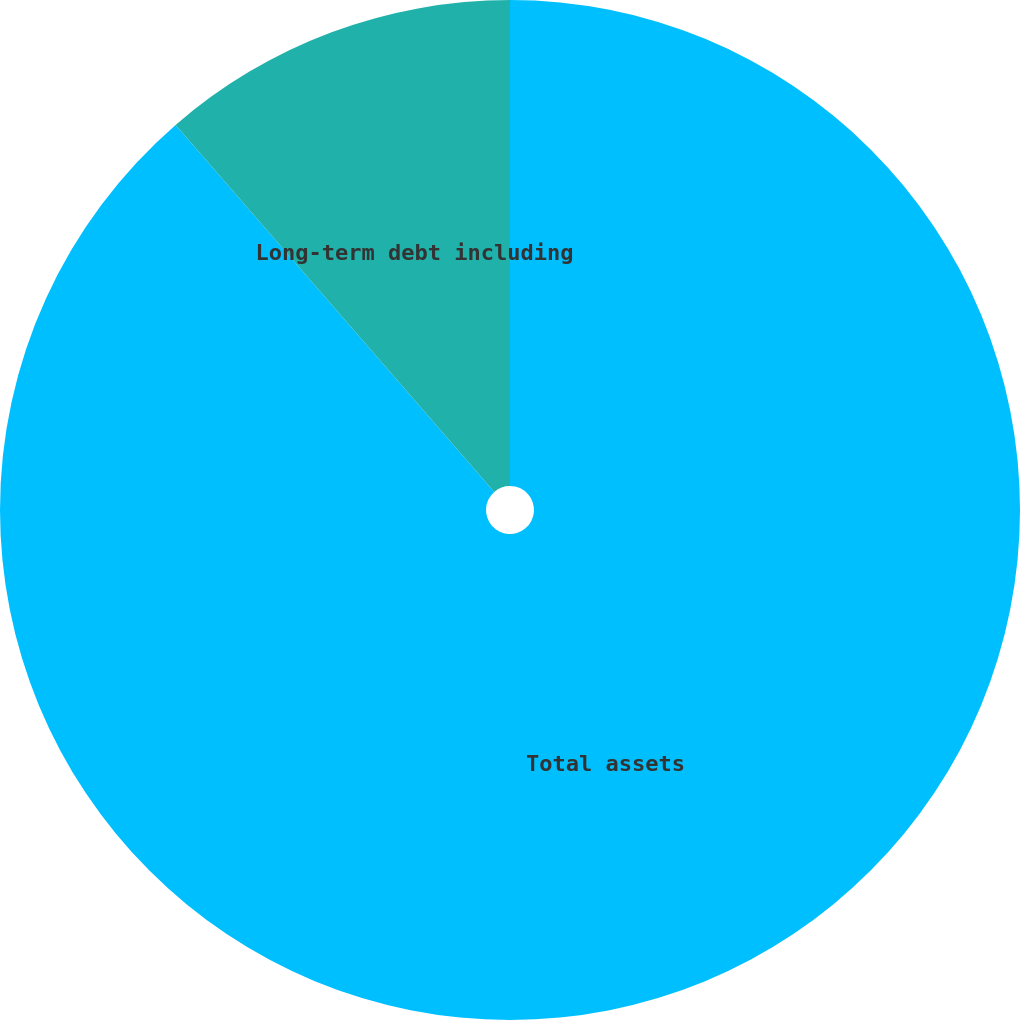Convert chart. <chart><loc_0><loc_0><loc_500><loc_500><pie_chart><fcel>Total assets<fcel>Long-term debt including<nl><fcel>88.62%<fcel>11.38%<nl></chart> 